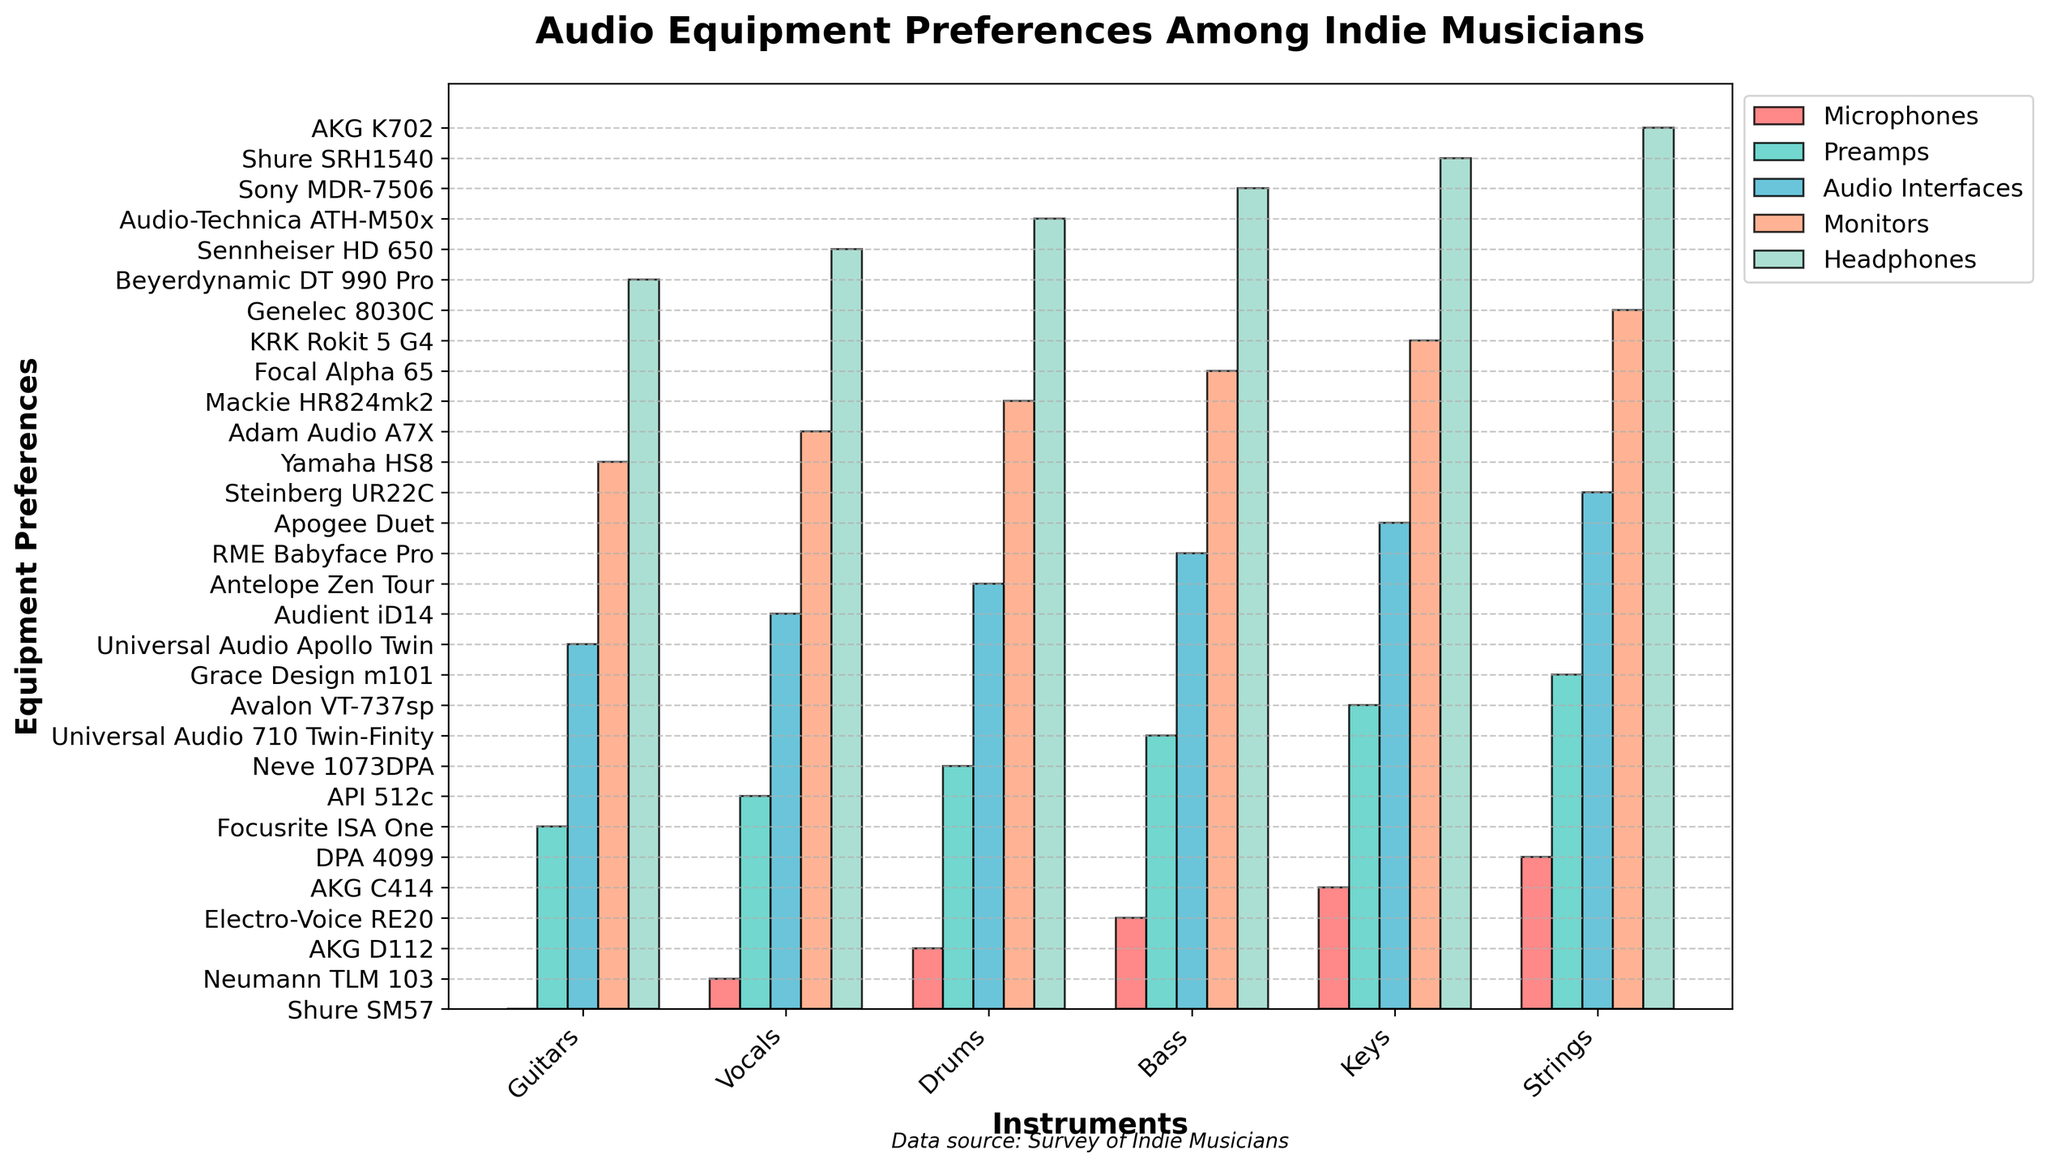Which instrument category prefers Neumann TLM 103 microphones? Look at the blue bars representing microphones in the chart; find the category reaching the same height as the textual label 'Neumann TLM 103'.
Answer: Vocals Which type of equipment has the most similar preferences between Vocals and Keys? Compare the bars (each representing a type of equipment) for height similarity; focusing on instances where the bar heights between Vocals and Keys are nearly equal.
Answer: Audio Interfaces What is the combined preference count for Shure equipment across all instrument categories? We need to scan through the equipment names and sum up all instances where "Shure" appears. In this chart, it involves Shure SM57 for Guitars, Shure SRH1540 for Keys.
Answer: 2 In which instrument category is the red bar (indicating microphones) the tallest? Observe the height of the red bars across all instrument categories to find the one with the maximum height.
Answer: Vocals Is the Adam Audio A7X monitor preferred by more than one instrument category? Look at the violet bars representing monitors and check if Adam Audio A7X is listed in several sections.
Answer: No Which instrument category has the least varied preferences overall? Observe the consistency in the height of the bars within a single category; the category with bars of nearly identical height will indicate the least variety in preferences.
Answer: Strings Which two types of equipment have the highest combined height for Bass? Identify the two tallest bars (among microphones, preamps, audio interfaces, monitors, and headphones) for the Bass category by comparing their heights visually.
Answer: Microphones and Preamps What is the average number of different microphone brands preferred across all instrument categories? Count the different microphone brands for each category and find the sum, then divide by the number of categories. Summarizing visually: 6 unique categories.
Answer: 1 Which instrument category prefers Universal Audio Apollo Twin for audio interfaces? Look at the green bars representing audio interfaces and note the category linked with Universal Audio Apollo Twin.
Answer: Guitars Which instrument category prefers API 512c for preamps? Look at the yellow bars representing preamps in the chart and find the instrument category listed "API 512c".
Answer: Vocals 